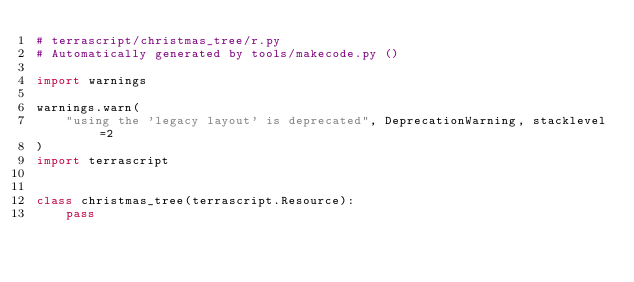<code> <loc_0><loc_0><loc_500><loc_500><_Python_># terrascript/christmas_tree/r.py
# Automatically generated by tools/makecode.py ()

import warnings

warnings.warn(
    "using the 'legacy layout' is deprecated", DeprecationWarning, stacklevel=2
)
import terrascript


class christmas_tree(terrascript.Resource):
    pass
</code> 